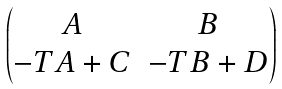<formula> <loc_0><loc_0><loc_500><loc_500>\begin{pmatrix} A & B \\ - T A + C & - T B + D \end{pmatrix}</formula> 